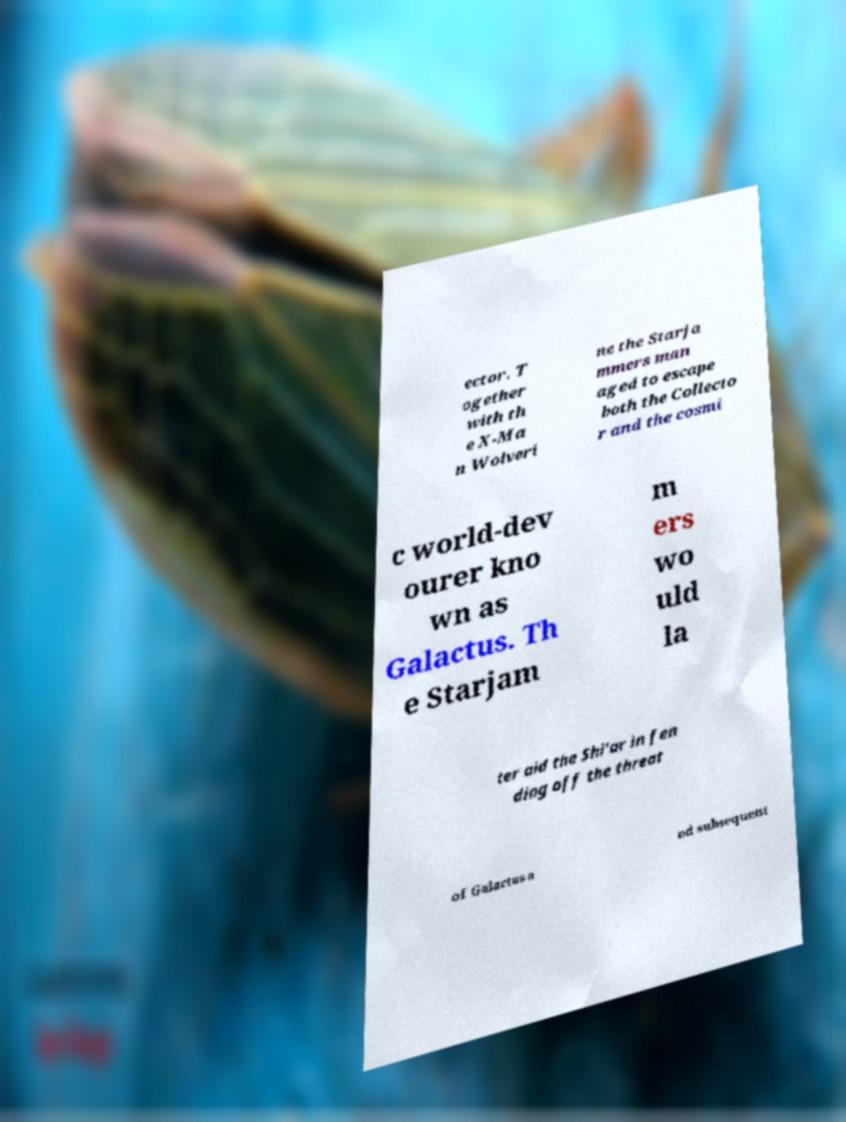Please identify and transcribe the text found in this image. ector. T ogether with th e X-Ma n Wolveri ne the Starja mmers man aged to escape both the Collecto r and the cosmi c world-dev ourer kno wn as Galactus. Th e Starjam m ers wo uld la ter aid the Shi'ar in fen ding off the threat of Galactus a nd subsequent 